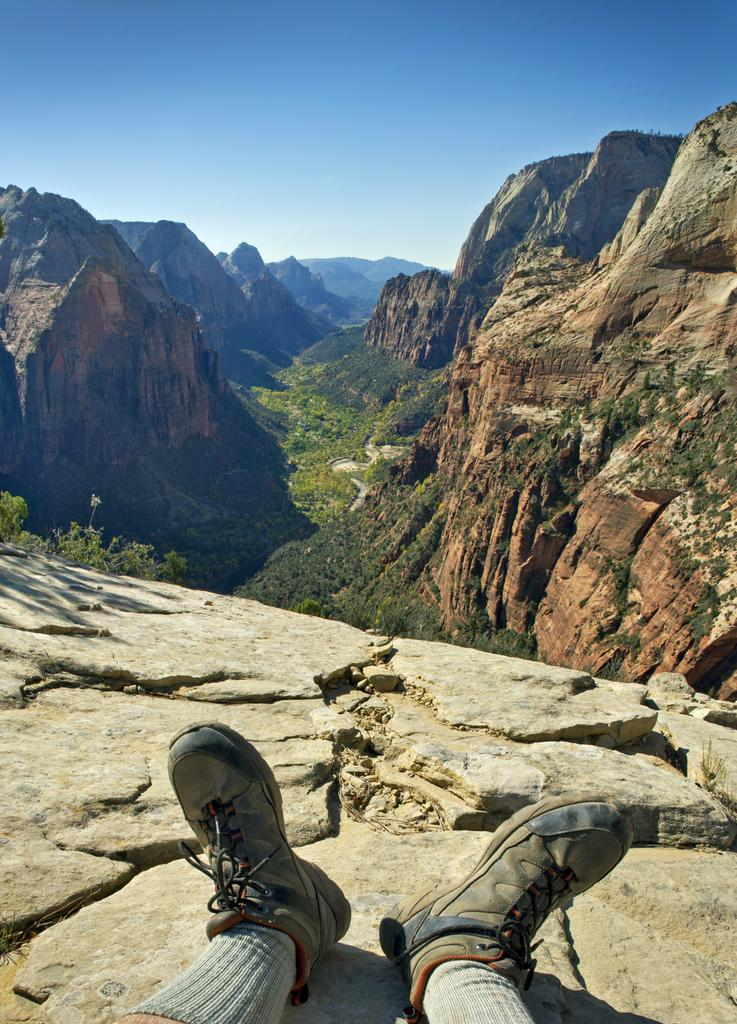What is present in the image? There is a person in the image. What is the person wearing on their feet? The person is wearing shoes and socks. Where is the person located in the image? The person is on the surface of a hill. What can be seen in the distance in the image? There are mountains in the background of the image. What color is the sky in the image? The sky is blue in the image. What type of organization does the person belong to in the image? There is no information about the person's organization in the image. How does the person sense the texture of the hill in the image? The image does not provide information about the person's sense of touch or any other senses. 